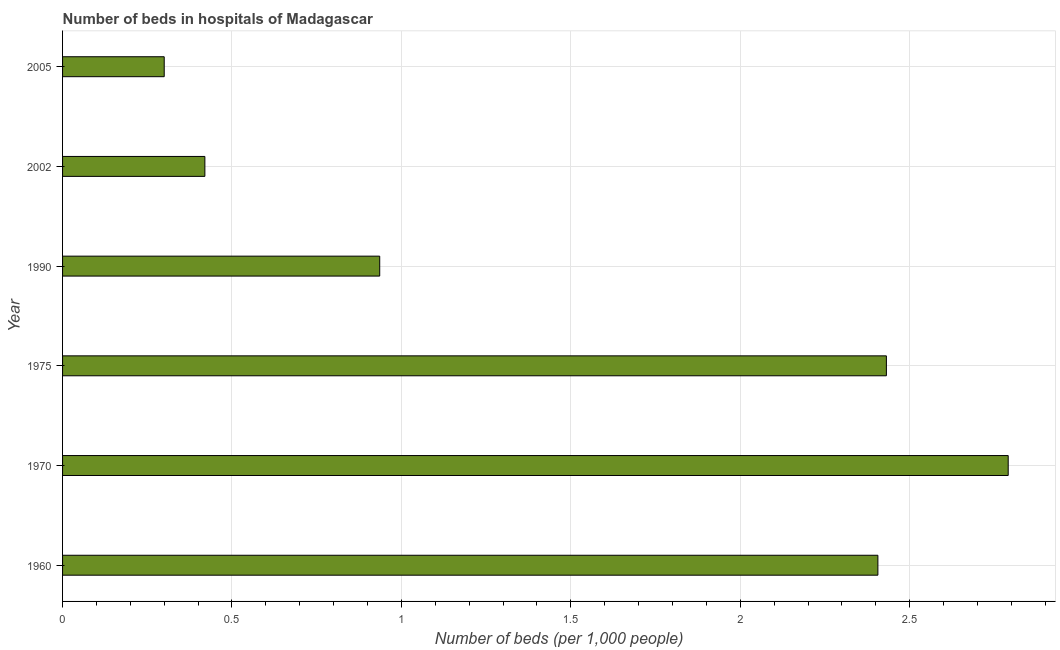Does the graph contain any zero values?
Offer a terse response. No. What is the title of the graph?
Your response must be concise. Number of beds in hospitals of Madagascar. What is the label or title of the X-axis?
Your response must be concise. Number of beds (per 1,0 people). What is the number of hospital beds in 1960?
Ensure brevity in your answer.  2.41. Across all years, what is the maximum number of hospital beds?
Your answer should be very brief. 2.79. Across all years, what is the minimum number of hospital beds?
Provide a short and direct response. 0.3. What is the sum of the number of hospital beds?
Ensure brevity in your answer.  9.28. What is the difference between the number of hospital beds in 1970 and 2002?
Make the answer very short. 2.37. What is the average number of hospital beds per year?
Your answer should be very brief. 1.55. What is the median number of hospital beds?
Make the answer very short. 1.67. In how many years, is the number of hospital beds greater than 1.7 %?
Offer a very short reply. 3. Do a majority of the years between 2002 and 2005 (inclusive) have number of hospital beds greater than 1.2 %?
Provide a succinct answer. No. What is the ratio of the number of hospital beds in 1990 to that in 2005?
Give a very brief answer. 3.12. What is the difference between the highest and the second highest number of hospital beds?
Offer a terse response. 0.36. Is the sum of the number of hospital beds in 1960 and 1970 greater than the maximum number of hospital beds across all years?
Your answer should be compact. Yes. What is the difference between the highest and the lowest number of hospital beds?
Make the answer very short. 2.49. In how many years, is the number of hospital beds greater than the average number of hospital beds taken over all years?
Provide a short and direct response. 3. Are all the bars in the graph horizontal?
Make the answer very short. Yes. What is the difference between two consecutive major ticks on the X-axis?
Give a very brief answer. 0.5. What is the Number of beds (per 1,000 people) of 1960?
Provide a short and direct response. 2.41. What is the Number of beds (per 1,000 people) of 1970?
Provide a short and direct response. 2.79. What is the Number of beds (per 1,000 people) in 1975?
Provide a succinct answer. 2.43. What is the Number of beds (per 1,000 people) in 1990?
Your answer should be very brief. 0.94. What is the Number of beds (per 1,000 people) of 2002?
Your response must be concise. 0.42. What is the Number of beds (per 1,000 people) in 2005?
Offer a terse response. 0.3. What is the difference between the Number of beds (per 1,000 people) in 1960 and 1970?
Provide a short and direct response. -0.38. What is the difference between the Number of beds (per 1,000 people) in 1960 and 1975?
Offer a terse response. -0.03. What is the difference between the Number of beds (per 1,000 people) in 1960 and 1990?
Ensure brevity in your answer.  1.47. What is the difference between the Number of beds (per 1,000 people) in 1960 and 2002?
Ensure brevity in your answer.  1.99. What is the difference between the Number of beds (per 1,000 people) in 1960 and 2005?
Offer a very short reply. 2.11. What is the difference between the Number of beds (per 1,000 people) in 1970 and 1975?
Your answer should be very brief. 0.36. What is the difference between the Number of beds (per 1,000 people) in 1970 and 1990?
Make the answer very short. 1.85. What is the difference between the Number of beds (per 1,000 people) in 1970 and 2002?
Provide a short and direct response. 2.37. What is the difference between the Number of beds (per 1,000 people) in 1970 and 2005?
Offer a very short reply. 2.49. What is the difference between the Number of beds (per 1,000 people) in 1975 and 1990?
Your answer should be compact. 1.5. What is the difference between the Number of beds (per 1,000 people) in 1975 and 2002?
Your response must be concise. 2.01. What is the difference between the Number of beds (per 1,000 people) in 1975 and 2005?
Your answer should be compact. 2.13. What is the difference between the Number of beds (per 1,000 people) in 1990 and 2002?
Your response must be concise. 0.52. What is the difference between the Number of beds (per 1,000 people) in 1990 and 2005?
Make the answer very short. 0.64. What is the difference between the Number of beds (per 1,000 people) in 2002 and 2005?
Make the answer very short. 0.12. What is the ratio of the Number of beds (per 1,000 people) in 1960 to that in 1970?
Your response must be concise. 0.86. What is the ratio of the Number of beds (per 1,000 people) in 1960 to that in 1975?
Offer a terse response. 0.99. What is the ratio of the Number of beds (per 1,000 people) in 1960 to that in 1990?
Offer a terse response. 2.57. What is the ratio of the Number of beds (per 1,000 people) in 1960 to that in 2002?
Offer a very short reply. 5.73. What is the ratio of the Number of beds (per 1,000 people) in 1960 to that in 2005?
Keep it short and to the point. 8.02. What is the ratio of the Number of beds (per 1,000 people) in 1970 to that in 1975?
Your response must be concise. 1.15. What is the ratio of the Number of beds (per 1,000 people) in 1970 to that in 1990?
Your answer should be compact. 2.98. What is the ratio of the Number of beds (per 1,000 people) in 1970 to that in 2002?
Offer a terse response. 6.64. What is the ratio of the Number of beds (per 1,000 people) in 1970 to that in 2005?
Your answer should be compact. 9.3. What is the ratio of the Number of beds (per 1,000 people) in 1975 to that in 1990?
Ensure brevity in your answer.  2.6. What is the ratio of the Number of beds (per 1,000 people) in 1975 to that in 2002?
Provide a succinct answer. 5.79. What is the ratio of the Number of beds (per 1,000 people) in 1975 to that in 2005?
Your answer should be very brief. 8.1. What is the ratio of the Number of beds (per 1,000 people) in 1990 to that in 2002?
Your response must be concise. 2.23. What is the ratio of the Number of beds (per 1,000 people) in 1990 to that in 2005?
Make the answer very short. 3.12. 